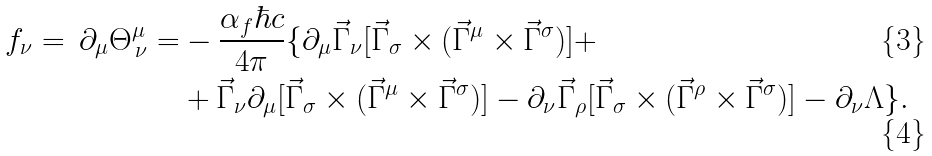<formula> <loc_0><loc_0><loc_500><loc_500>f _ { \nu } = \, \partial _ { \mu } \Theta ^ { \mu } _ { \, \nu } = & - \frac { \alpha _ { f } \hbar { c } } { 4 \pi } \{ \partial _ { \mu } \vec { \Gamma } _ { \nu } [ \vec { \Gamma } _ { \sigma } \times ( \vec { \Gamma } ^ { \mu } \times \vec { \Gamma } ^ { \sigma } ) ] + \\ & + \vec { \Gamma } _ { \nu } \partial _ { \mu } [ \vec { \Gamma } _ { \sigma } \times ( \vec { \Gamma } ^ { \mu } \times \vec { \Gamma } ^ { \sigma } ) ] - \partial _ { \nu } \vec { \Gamma } _ { \rho } [ \vec { \Gamma } _ { \sigma } \times ( \vec { \Gamma } ^ { \rho } \times \vec { \Gamma } ^ { \sigma } ) ] - \partial _ { \nu } \Lambda \} .</formula> 